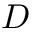<formula> <loc_0><loc_0><loc_500><loc_500>D</formula> 